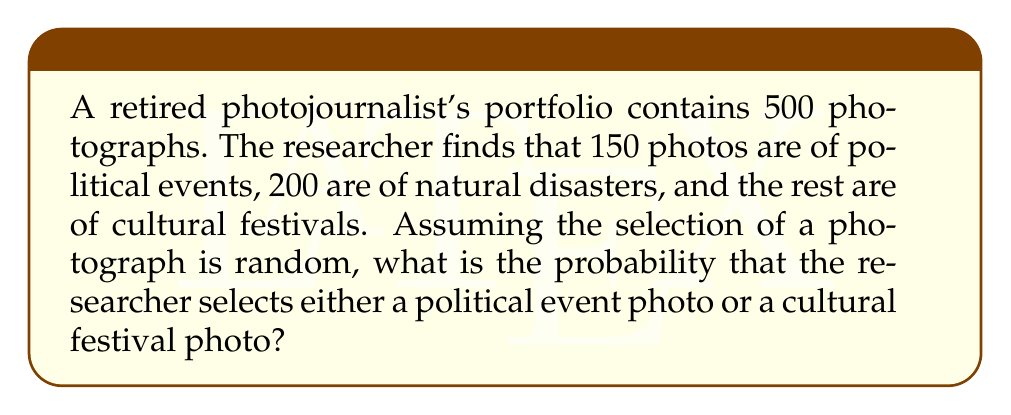Could you help me with this problem? Let's approach this step-by-step:

1) First, we need to determine the number of cultural festival photos:
   Total photos = 500
   Political events = 150
   Natural disasters = 200
   Cultural festivals = 500 - 150 - 200 = 150

2) Now, we need to calculate the probability of selecting either a political event photo or a cultural festival photo. This is a union of two events.

3) Let's define our events:
   P = selecting a political event photo
   C = selecting a cultural festival photo

4) We want to find P(P ∪ C), which is given by:
   P(P ∪ C) = P(P) + P(C) - P(P ∩ C)

5) Calculate individual probabilities:
   P(P) = 150/500 = 3/10
   P(C) = 150/500 = 3/10

6) Since the events are mutually exclusive (a photo can't be both a political event and a cultural festival), P(P ∩ C) = 0

7) Therefore:
   P(P ∪ C) = P(P) + P(C) - P(P ∩ C)
             = 3/10 + 3/10 - 0
             = 6/10
             = 3/5

8) Convert to a percentage:
   3/5 * 100 = 60%
Answer: 60% 